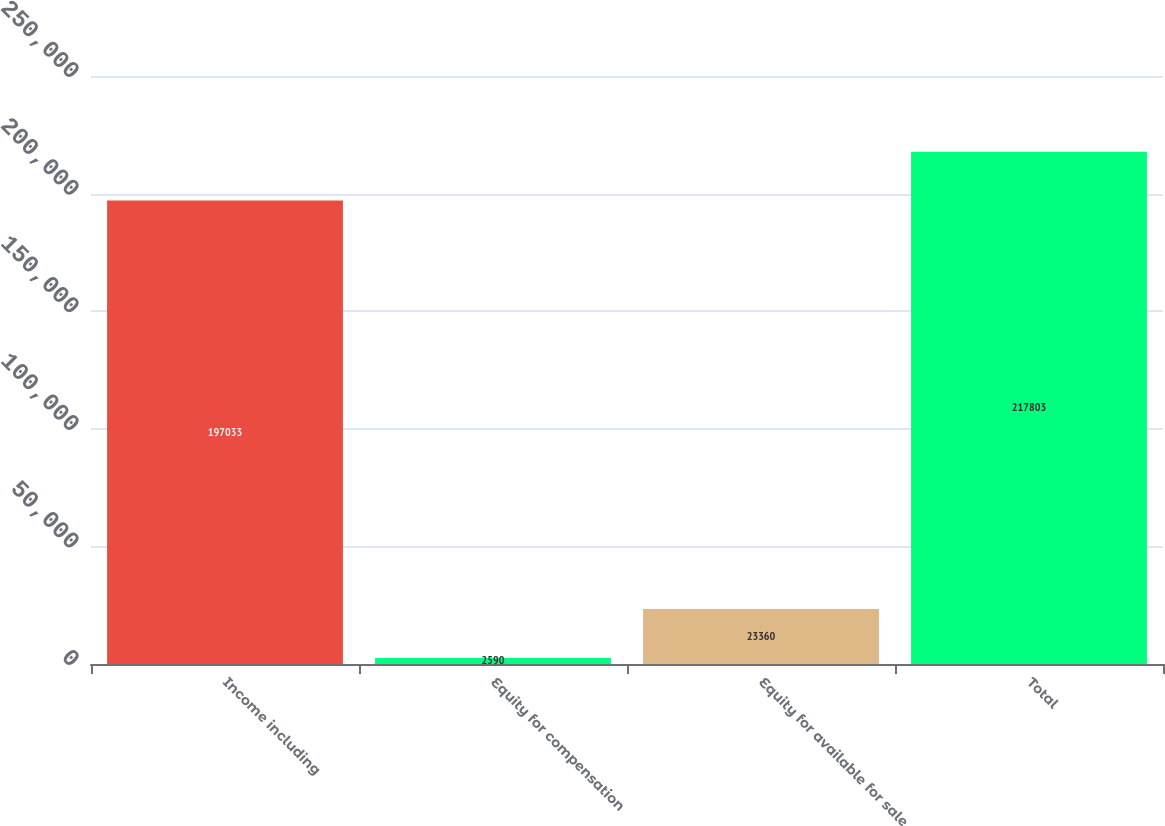Convert chart to OTSL. <chart><loc_0><loc_0><loc_500><loc_500><bar_chart><fcel>Income including<fcel>Equity for compensation<fcel>Equity for available for sale<fcel>Total<nl><fcel>197033<fcel>2590<fcel>23360<fcel>217803<nl></chart> 